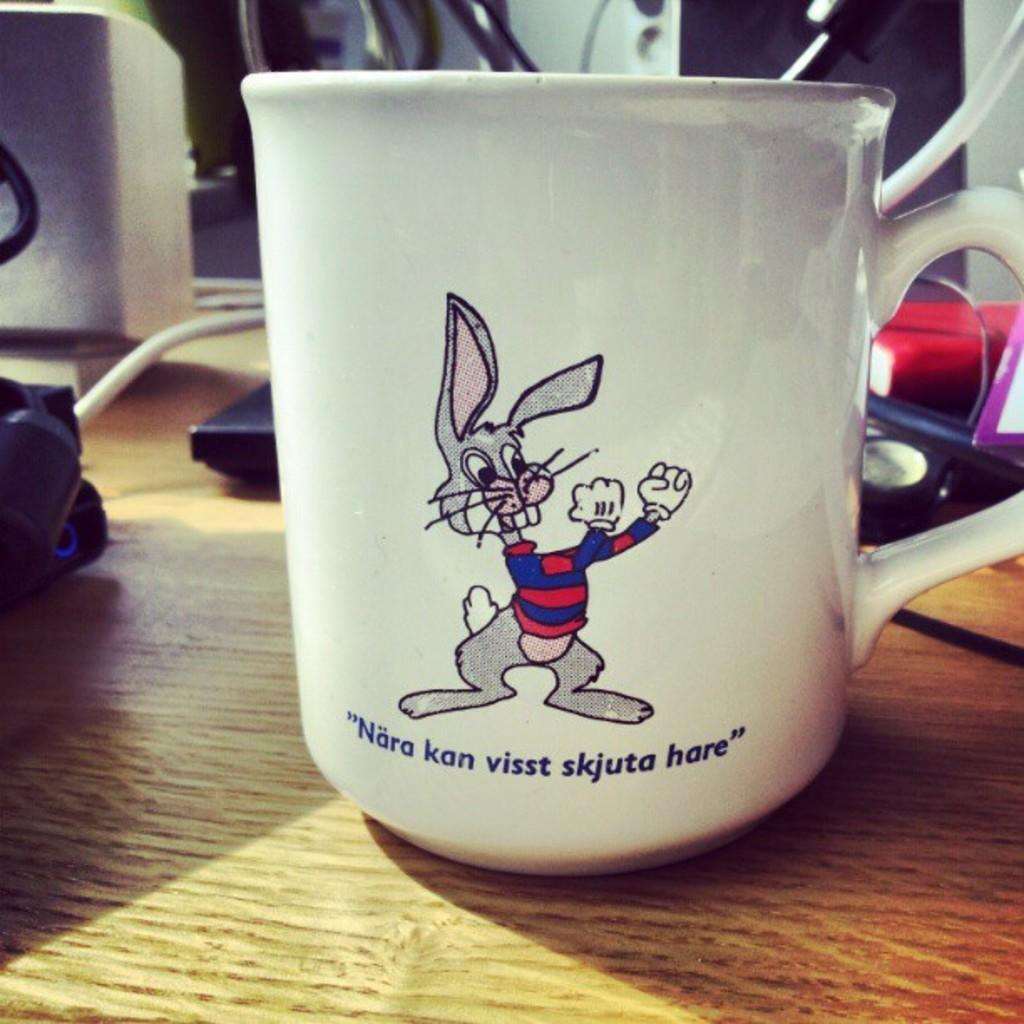<image>
Present a compact description of the photo's key features. A mug with a rabbit has hare as the last word on the front. 